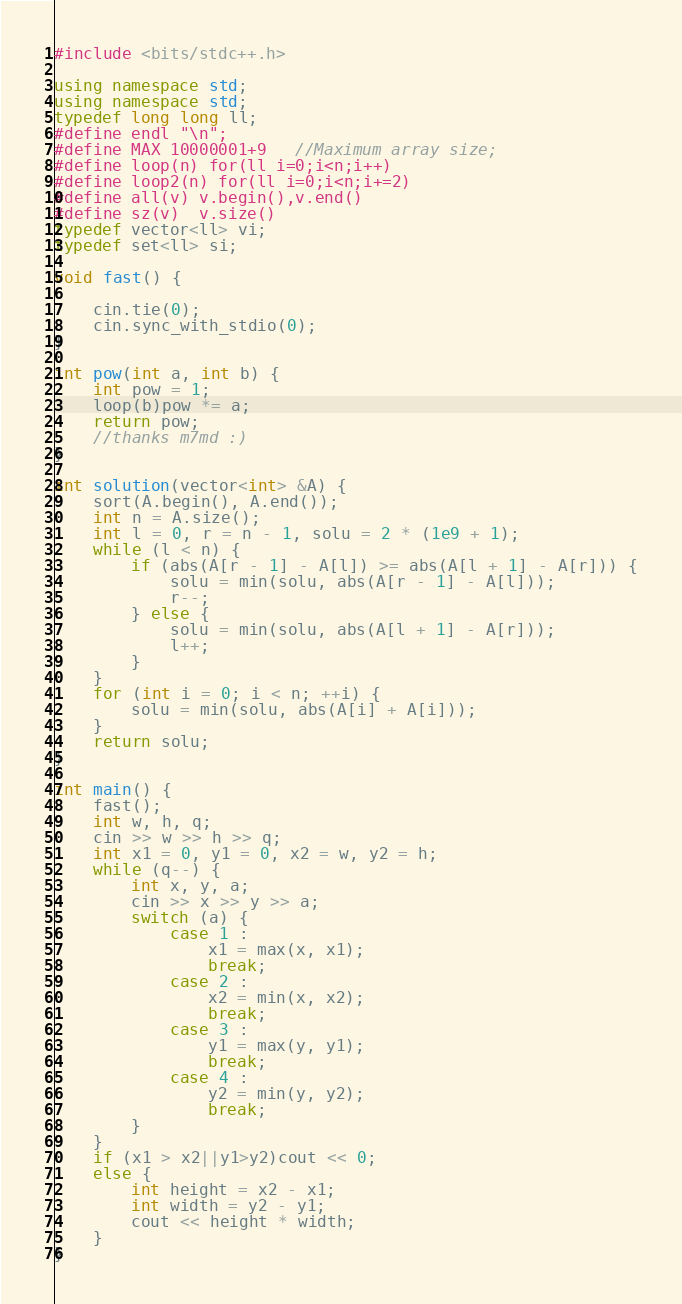Convert code to text. <code><loc_0><loc_0><loc_500><loc_500><_C++_>#include <bits/stdc++.h>

using namespace std;
using namespace std;
typedef long long ll;
#define endl "\n";
#define MAX 10000001+9   //Maximum array size;
#define loop(n) for(ll i=0;i<n;i++)
#define loop2(n) for(ll i=0;i<n;i+=2)
#define all(v) v.begin(),v.end()
#define sz(v)  v.size()
typedef vector<ll> vi;
typedef set<ll> si;

void fast() {

    cin.tie(0);
    cin.sync_with_stdio(0);
}

int pow(int a, int b) {
    int pow = 1;
    loop(b)pow *= a;
    return pow;
    //thanks m7md :)
}

int solution(vector<int> &A) {
    sort(A.begin(), A.end());
    int n = A.size();
    int l = 0, r = n - 1, solu = 2 * (1e9 + 1);
    while (l < n) {
        if (abs(A[r - 1] - A[l]) >= abs(A[l + 1] - A[r])) {
            solu = min(solu, abs(A[r - 1] - A[l]));
            r--;
        } else {
            solu = min(solu, abs(A[l + 1] - A[r]));
            l++;
        }
    }
    for (int i = 0; i < n; ++i) {
        solu = min(solu, abs(A[i] + A[i]));
    }
    return solu;
}

int main() {
    fast();
    int w, h, q;
    cin >> w >> h >> q;
    int x1 = 0, y1 = 0, x2 = w, y2 = h;
    while (q--) {
        int x, y, a;
        cin >> x >> y >> a;
        switch (a) {
            case 1 :
                x1 = max(x, x1);
                break;
            case 2 :
                x2 = min(x, x2);
                break;
            case 3 :
                y1 = max(y, y1);
                break;
            case 4 :
                y2 = min(y, y2);
                break;
        }
    }
    if (x1 > x2||y1>y2)cout << 0;
    else {
        int height = x2 - x1;
        int width = y2 - y1;
        cout << height * width;
    }
}</code> 